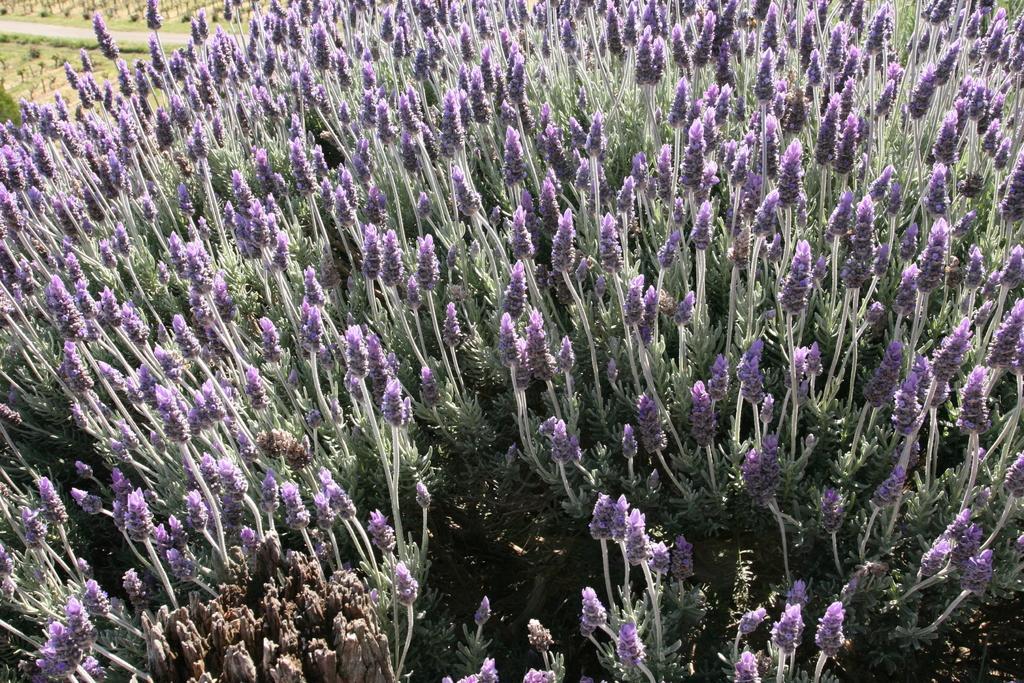How would you summarize this image in a sentence or two? In this image we can see purple color flower field. 